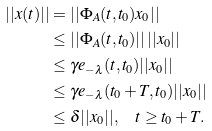Convert formula to latex. <formula><loc_0><loc_0><loc_500><loc_500>| | x ( t ) | | & = | | \Phi _ { A } ( t , t _ { 0 } ) x _ { 0 } | | \\ & \leq | | \Phi _ { A } ( t , t _ { 0 } ) | | \, | | x _ { 0 } | | \\ & \leq \gamma e _ { - \lambda } ( t , t _ { 0 } ) | | x _ { 0 } | | \\ & \leq \gamma e _ { - \lambda } ( t _ { 0 } + T , t _ { 0 } ) | | x _ { 0 } | | \\ & \leq \delta | | x _ { 0 } | | , \quad t \geq t _ { 0 } + T .</formula> 